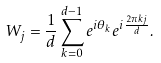<formula> <loc_0><loc_0><loc_500><loc_500>W _ { j } = \frac { 1 } { d } \sum _ { k = 0 } ^ { d - 1 } e ^ { i \theta _ { k } } e ^ { i \frac { 2 \pi k j } { d } } .</formula> 